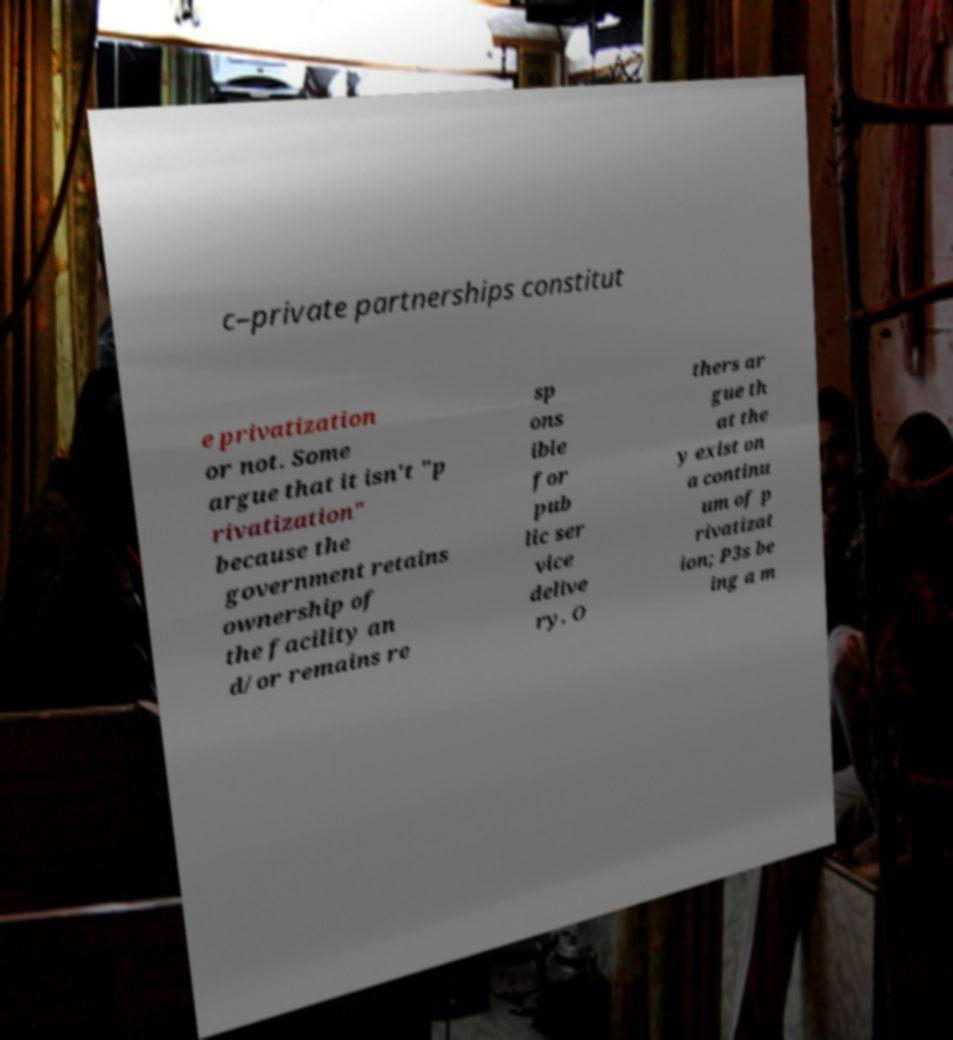There's text embedded in this image that I need extracted. Can you transcribe it verbatim? c–private partnerships constitut e privatization or not. Some argue that it isn't "p rivatization" because the government retains ownership of the facility an d/or remains re sp ons ible for pub lic ser vice delive ry. O thers ar gue th at the y exist on a continu um of p rivatizat ion; P3s be ing a m 